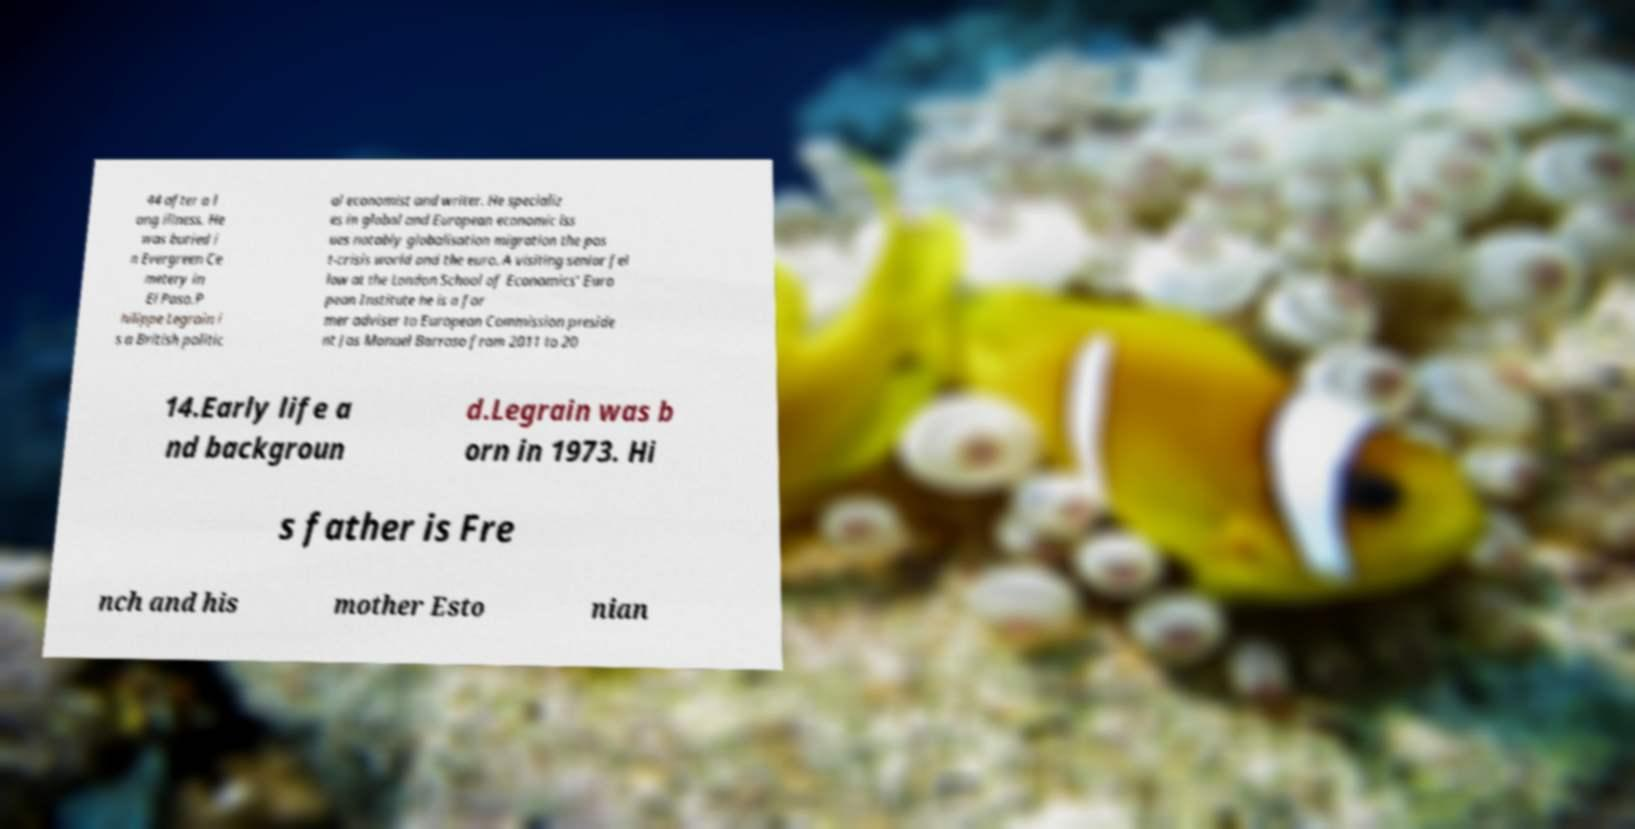There's text embedded in this image that I need extracted. Can you transcribe it verbatim? 44 after a l ong illness. He was buried i n Evergreen Ce metery in El Paso.P hilippe Legrain i s a British politic al economist and writer. He specializ es in global and European economic iss ues notably globalisation migration the pos t-crisis world and the euro. A visiting senior fel low at the London School of Economics' Euro pean Institute he is a for mer adviser to European Commission preside nt Jos Manuel Barroso from 2011 to 20 14.Early life a nd backgroun d.Legrain was b orn in 1973. Hi s father is Fre nch and his mother Esto nian 